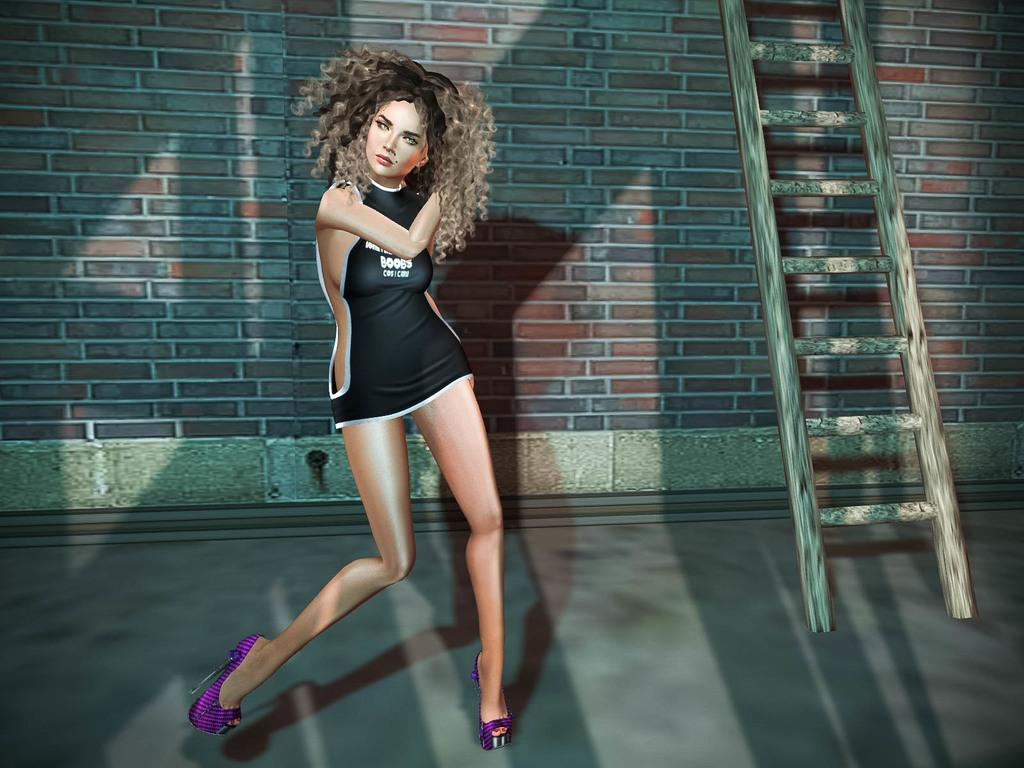<image>
Describe the image concisely. A woman is dancing in a revealing dress with the word Boobs on the front. 